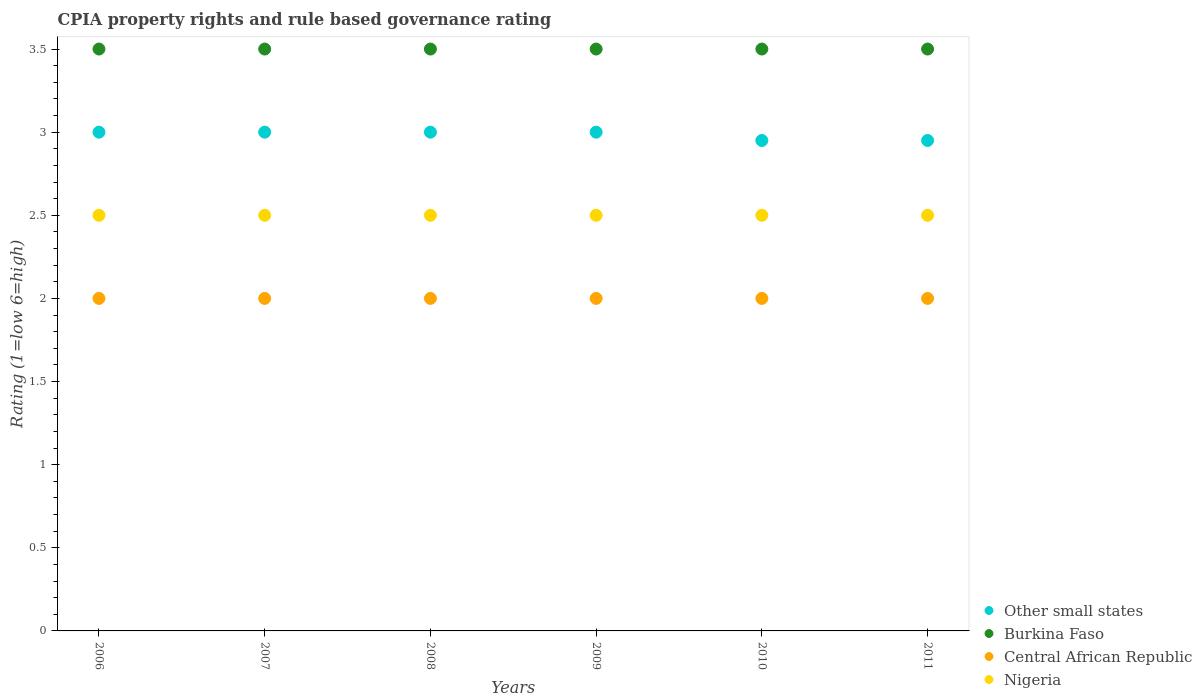How many different coloured dotlines are there?
Give a very brief answer. 4. Is the number of dotlines equal to the number of legend labels?
Give a very brief answer. Yes. Across all years, what is the maximum CPIA rating in Nigeria?
Give a very brief answer. 2.5. Across all years, what is the minimum CPIA rating in Other small states?
Ensure brevity in your answer.  2.95. In which year was the CPIA rating in Other small states maximum?
Your response must be concise. 2006. What is the total CPIA rating in Other small states in the graph?
Give a very brief answer. 17.9. What is the difference between the CPIA rating in Central African Republic in 2010 and the CPIA rating in Nigeria in 2008?
Give a very brief answer. -0.5. What is the average CPIA rating in Burkina Faso per year?
Your response must be concise. 3.5. In the year 2008, what is the difference between the CPIA rating in Burkina Faso and CPIA rating in Central African Republic?
Your response must be concise. 1.5. What is the difference between the highest and the second highest CPIA rating in Central African Republic?
Provide a succinct answer. 0. In how many years, is the CPIA rating in Other small states greater than the average CPIA rating in Other small states taken over all years?
Your answer should be compact. 4. Is it the case that in every year, the sum of the CPIA rating in Nigeria and CPIA rating in Central African Republic  is greater than the sum of CPIA rating in Other small states and CPIA rating in Burkina Faso?
Provide a short and direct response. Yes. Does the CPIA rating in Central African Republic monotonically increase over the years?
Your answer should be very brief. No. Is the CPIA rating in Nigeria strictly greater than the CPIA rating in Central African Republic over the years?
Keep it short and to the point. Yes. Is the CPIA rating in Central African Republic strictly less than the CPIA rating in Other small states over the years?
Keep it short and to the point. Yes. What is the difference between two consecutive major ticks on the Y-axis?
Ensure brevity in your answer.  0.5. Does the graph contain any zero values?
Your answer should be compact. No. Does the graph contain grids?
Make the answer very short. No. Where does the legend appear in the graph?
Your response must be concise. Bottom right. How many legend labels are there?
Your response must be concise. 4. How are the legend labels stacked?
Your response must be concise. Vertical. What is the title of the graph?
Offer a terse response. CPIA property rights and rule based governance rating. What is the label or title of the Y-axis?
Your answer should be compact. Rating (1=low 6=high). What is the Rating (1=low 6=high) of Burkina Faso in 2006?
Your answer should be very brief. 3.5. What is the Rating (1=low 6=high) in Nigeria in 2006?
Your answer should be very brief. 2.5. What is the Rating (1=low 6=high) in Central African Republic in 2007?
Ensure brevity in your answer.  2. What is the Rating (1=low 6=high) in Nigeria in 2007?
Make the answer very short. 2.5. What is the Rating (1=low 6=high) in Burkina Faso in 2009?
Provide a short and direct response. 3.5. What is the Rating (1=low 6=high) in Central African Republic in 2009?
Offer a terse response. 2. What is the Rating (1=low 6=high) of Other small states in 2010?
Your answer should be compact. 2.95. What is the Rating (1=low 6=high) in Central African Republic in 2010?
Give a very brief answer. 2. What is the Rating (1=low 6=high) of Other small states in 2011?
Provide a short and direct response. 2.95. What is the Rating (1=low 6=high) of Burkina Faso in 2011?
Offer a very short reply. 3.5. What is the Rating (1=low 6=high) in Nigeria in 2011?
Offer a very short reply. 2.5. Across all years, what is the maximum Rating (1=low 6=high) of Nigeria?
Your response must be concise. 2.5. Across all years, what is the minimum Rating (1=low 6=high) of Other small states?
Give a very brief answer. 2.95. Across all years, what is the minimum Rating (1=low 6=high) in Burkina Faso?
Ensure brevity in your answer.  3.5. Across all years, what is the minimum Rating (1=low 6=high) in Nigeria?
Offer a terse response. 2.5. What is the total Rating (1=low 6=high) in Other small states in the graph?
Offer a terse response. 17.9. What is the total Rating (1=low 6=high) of Nigeria in the graph?
Make the answer very short. 15. What is the difference between the Rating (1=low 6=high) of Other small states in 2006 and that in 2007?
Your response must be concise. 0. What is the difference between the Rating (1=low 6=high) of Central African Republic in 2006 and that in 2007?
Provide a succinct answer. 0. What is the difference between the Rating (1=low 6=high) of Nigeria in 2006 and that in 2007?
Keep it short and to the point. 0. What is the difference between the Rating (1=low 6=high) of Other small states in 2006 and that in 2008?
Ensure brevity in your answer.  0. What is the difference between the Rating (1=low 6=high) in Burkina Faso in 2006 and that in 2008?
Offer a terse response. 0. What is the difference between the Rating (1=low 6=high) in Burkina Faso in 2006 and that in 2009?
Keep it short and to the point. 0. What is the difference between the Rating (1=low 6=high) of Other small states in 2006 and that in 2010?
Offer a terse response. 0.05. What is the difference between the Rating (1=low 6=high) of Burkina Faso in 2006 and that in 2010?
Your answer should be very brief. 0. What is the difference between the Rating (1=low 6=high) in Burkina Faso in 2006 and that in 2011?
Offer a terse response. 0. What is the difference between the Rating (1=low 6=high) in Central African Republic in 2006 and that in 2011?
Offer a terse response. 0. What is the difference between the Rating (1=low 6=high) of Burkina Faso in 2007 and that in 2008?
Provide a short and direct response. 0. What is the difference between the Rating (1=low 6=high) of Nigeria in 2007 and that in 2008?
Your response must be concise. 0. What is the difference between the Rating (1=low 6=high) in Other small states in 2007 and that in 2009?
Your answer should be compact. 0. What is the difference between the Rating (1=low 6=high) in Burkina Faso in 2007 and that in 2009?
Offer a terse response. 0. What is the difference between the Rating (1=low 6=high) in Central African Republic in 2007 and that in 2009?
Offer a very short reply. 0. What is the difference between the Rating (1=low 6=high) in Burkina Faso in 2007 and that in 2010?
Offer a very short reply. 0. What is the difference between the Rating (1=low 6=high) in Other small states in 2007 and that in 2011?
Make the answer very short. 0.05. What is the difference between the Rating (1=low 6=high) of Burkina Faso in 2007 and that in 2011?
Keep it short and to the point. 0. What is the difference between the Rating (1=low 6=high) in Central African Republic in 2007 and that in 2011?
Ensure brevity in your answer.  0. What is the difference between the Rating (1=low 6=high) in Nigeria in 2007 and that in 2011?
Your answer should be compact. 0. What is the difference between the Rating (1=low 6=high) in Other small states in 2008 and that in 2009?
Your answer should be very brief. 0. What is the difference between the Rating (1=low 6=high) in Nigeria in 2008 and that in 2009?
Ensure brevity in your answer.  0. What is the difference between the Rating (1=low 6=high) of Other small states in 2008 and that in 2010?
Make the answer very short. 0.05. What is the difference between the Rating (1=low 6=high) of Burkina Faso in 2008 and that in 2011?
Make the answer very short. 0. What is the difference between the Rating (1=low 6=high) of Other small states in 2009 and that in 2010?
Offer a terse response. 0.05. What is the difference between the Rating (1=low 6=high) in Burkina Faso in 2009 and that in 2010?
Your answer should be very brief. 0. What is the difference between the Rating (1=low 6=high) of Nigeria in 2009 and that in 2010?
Offer a very short reply. 0. What is the difference between the Rating (1=low 6=high) of Burkina Faso in 2009 and that in 2011?
Provide a succinct answer. 0. What is the difference between the Rating (1=low 6=high) of Central African Republic in 2009 and that in 2011?
Keep it short and to the point. 0. What is the difference between the Rating (1=low 6=high) of Nigeria in 2009 and that in 2011?
Provide a succinct answer. 0. What is the difference between the Rating (1=low 6=high) in Other small states in 2010 and that in 2011?
Your response must be concise. 0. What is the difference between the Rating (1=low 6=high) in Burkina Faso in 2010 and that in 2011?
Your answer should be very brief. 0. What is the difference between the Rating (1=low 6=high) of Nigeria in 2010 and that in 2011?
Offer a terse response. 0. What is the difference between the Rating (1=low 6=high) in Burkina Faso in 2006 and the Rating (1=low 6=high) in Central African Republic in 2007?
Give a very brief answer. 1.5. What is the difference between the Rating (1=low 6=high) in Burkina Faso in 2006 and the Rating (1=low 6=high) in Nigeria in 2007?
Offer a terse response. 1. What is the difference between the Rating (1=low 6=high) of Central African Republic in 2006 and the Rating (1=low 6=high) of Nigeria in 2007?
Your answer should be very brief. -0.5. What is the difference between the Rating (1=low 6=high) in Other small states in 2006 and the Rating (1=low 6=high) in Central African Republic in 2008?
Your answer should be compact. 1. What is the difference between the Rating (1=low 6=high) in Burkina Faso in 2006 and the Rating (1=low 6=high) in Central African Republic in 2008?
Provide a succinct answer. 1.5. What is the difference between the Rating (1=low 6=high) of Burkina Faso in 2006 and the Rating (1=low 6=high) of Nigeria in 2008?
Give a very brief answer. 1. What is the difference between the Rating (1=low 6=high) of Central African Republic in 2006 and the Rating (1=low 6=high) of Nigeria in 2008?
Offer a terse response. -0.5. What is the difference between the Rating (1=low 6=high) of Other small states in 2006 and the Rating (1=low 6=high) of Nigeria in 2009?
Provide a succinct answer. 0.5. What is the difference between the Rating (1=low 6=high) in Burkina Faso in 2006 and the Rating (1=low 6=high) in Central African Republic in 2009?
Provide a succinct answer. 1.5. What is the difference between the Rating (1=low 6=high) in Burkina Faso in 2006 and the Rating (1=low 6=high) in Nigeria in 2009?
Provide a short and direct response. 1. What is the difference between the Rating (1=low 6=high) in Central African Republic in 2006 and the Rating (1=low 6=high) in Nigeria in 2009?
Provide a short and direct response. -0.5. What is the difference between the Rating (1=low 6=high) of Other small states in 2006 and the Rating (1=low 6=high) of Central African Republic in 2010?
Make the answer very short. 1. What is the difference between the Rating (1=low 6=high) in Burkina Faso in 2006 and the Rating (1=low 6=high) in Central African Republic in 2010?
Your answer should be compact. 1.5. What is the difference between the Rating (1=low 6=high) of Burkina Faso in 2006 and the Rating (1=low 6=high) of Nigeria in 2010?
Keep it short and to the point. 1. What is the difference between the Rating (1=low 6=high) of Central African Republic in 2006 and the Rating (1=low 6=high) of Nigeria in 2010?
Ensure brevity in your answer.  -0.5. What is the difference between the Rating (1=low 6=high) of Other small states in 2006 and the Rating (1=low 6=high) of Burkina Faso in 2011?
Make the answer very short. -0.5. What is the difference between the Rating (1=low 6=high) in Other small states in 2006 and the Rating (1=low 6=high) in Central African Republic in 2011?
Keep it short and to the point. 1. What is the difference between the Rating (1=low 6=high) of Other small states in 2006 and the Rating (1=low 6=high) of Nigeria in 2011?
Offer a terse response. 0.5. What is the difference between the Rating (1=low 6=high) of Burkina Faso in 2006 and the Rating (1=low 6=high) of Nigeria in 2011?
Your answer should be compact. 1. What is the difference between the Rating (1=low 6=high) of Burkina Faso in 2007 and the Rating (1=low 6=high) of Central African Republic in 2008?
Your answer should be compact. 1.5. What is the difference between the Rating (1=low 6=high) of Other small states in 2007 and the Rating (1=low 6=high) of Burkina Faso in 2009?
Give a very brief answer. -0.5. What is the difference between the Rating (1=low 6=high) of Central African Republic in 2007 and the Rating (1=low 6=high) of Nigeria in 2009?
Make the answer very short. -0.5. What is the difference between the Rating (1=low 6=high) in Burkina Faso in 2007 and the Rating (1=low 6=high) in Central African Republic in 2010?
Give a very brief answer. 1.5. What is the difference between the Rating (1=low 6=high) of Central African Republic in 2007 and the Rating (1=low 6=high) of Nigeria in 2010?
Provide a short and direct response. -0.5. What is the difference between the Rating (1=low 6=high) of Other small states in 2007 and the Rating (1=low 6=high) of Burkina Faso in 2011?
Ensure brevity in your answer.  -0.5. What is the difference between the Rating (1=low 6=high) in Other small states in 2007 and the Rating (1=low 6=high) in Central African Republic in 2011?
Ensure brevity in your answer.  1. What is the difference between the Rating (1=low 6=high) in Other small states in 2007 and the Rating (1=low 6=high) in Nigeria in 2011?
Keep it short and to the point. 0.5. What is the difference between the Rating (1=low 6=high) of Burkina Faso in 2007 and the Rating (1=low 6=high) of Central African Republic in 2011?
Provide a short and direct response. 1.5. What is the difference between the Rating (1=low 6=high) in Burkina Faso in 2007 and the Rating (1=low 6=high) in Nigeria in 2011?
Your response must be concise. 1. What is the difference between the Rating (1=low 6=high) in Central African Republic in 2007 and the Rating (1=low 6=high) in Nigeria in 2011?
Your answer should be very brief. -0.5. What is the difference between the Rating (1=low 6=high) in Other small states in 2008 and the Rating (1=low 6=high) in Nigeria in 2009?
Provide a succinct answer. 0.5. What is the difference between the Rating (1=low 6=high) in Burkina Faso in 2008 and the Rating (1=low 6=high) in Central African Republic in 2009?
Your answer should be very brief. 1.5. What is the difference between the Rating (1=low 6=high) of Other small states in 2008 and the Rating (1=low 6=high) of Central African Republic in 2010?
Make the answer very short. 1. What is the difference between the Rating (1=low 6=high) of Burkina Faso in 2008 and the Rating (1=low 6=high) of Nigeria in 2010?
Your response must be concise. 1. What is the difference between the Rating (1=low 6=high) in Other small states in 2008 and the Rating (1=low 6=high) in Burkina Faso in 2011?
Provide a short and direct response. -0.5. What is the difference between the Rating (1=low 6=high) in Other small states in 2008 and the Rating (1=low 6=high) in Central African Republic in 2011?
Ensure brevity in your answer.  1. What is the difference between the Rating (1=low 6=high) of Central African Republic in 2008 and the Rating (1=low 6=high) of Nigeria in 2011?
Your response must be concise. -0.5. What is the difference between the Rating (1=low 6=high) in Other small states in 2009 and the Rating (1=low 6=high) in Burkina Faso in 2010?
Your answer should be very brief. -0.5. What is the difference between the Rating (1=low 6=high) in Other small states in 2009 and the Rating (1=low 6=high) in Central African Republic in 2010?
Your response must be concise. 1. What is the difference between the Rating (1=low 6=high) in Other small states in 2009 and the Rating (1=low 6=high) in Nigeria in 2010?
Make the answer very short. 0.5. What is the difference between the Rating (1=low 6=high) of Burkina Faso in 2009 and the Rating (1=low 6=high) of Central African Republic in 2010?
Offer a very short reply. 1.5. What is the difference between the Rating (1=low 6=high) of Burkina Faso in 2009 and the Rating (1=low 6=high) of Nigeria in 2010?
Keep it short and to the point. 1. What is the difference between the Rating (1=low 6=high) of Other small states in 2009 and the Rating (1=low 6=high) of Nigeria in 2011?
Keep it short and to the point. 0.5. What is the difference between the Rating (1=low 6=high) of Burkina Faso in 2009 and the Rating (1=low 6=high) of Central African Republic in 2011?
Offer a very short reply. 1.5. What is the difference between the Rating (1=low 6=high) in Burkina Faso in 2009 and the Rating (1=low 6=high) in Nigeria in 2011?
Provide a succinct answer. 1. What is the difference between the Rating (1=low 6=high) in Central African Republic in 2009 and the Rating (1=low 6=high) in Nigeria in 2011?
Your answer should be very brief. -0.5. What is the difference between the Rating (1=low 6=high) of Other small states in 2010 and the Rating (1=low 6=high) of Burkina Faso in 2011?
Offer a very short reply. -0.55. What is the difference between the Rating (1=low 6=high) of Other small states in 2010 and the Rating (1=low 6=high) of Central African Republic in 2011?
Your answer should be compact. 0.95. What is the difference between the Rating (1=low 6=high) in Other small states in 2010 and the Rating (1=low 6=high) in Nigeria in 2011?
Your response must be concise. 0.45. What is the difference between the Rating (1=low 6=high) of Burkina Faso in 2010 and the Rating (1=low 6=high) of Central African Republic in 2011?
Your response must be concise. 1.5. What is the difference between the Rating (1=low 6=high) of Burkina Faso in 2010 and the Rating (1=low 6=high) of Nigeria in 2011?
Give a very brief answer. 1. What is the difference between the Rating (1=low 6=high) in Central African Republic in 2010 and the Rating (1=low 6=high) in Nigeria in 2011?
Ensure brevity in your answer.  -0.5. What is the average Rating (1=low 6=high) of Other small states per year?
Your answer should be compact. 2.98. What is the average Rating (1=low 6=high) of Central African Republic per year?
Offer a very short reply. 2. In the year 2006, what is the difference between the Rating (1=low 6=high) of Other small states and Rating (1=low 6=high) of Burkina Faso?
Give a very brief answer. -0.5. In the year 2006, what is the difference between the Rating (1=low 6=high) in Other small states and Rating (1=low 6=high) in Central African Republic?
Your answer should be very brief. 1. In the year 2006, what is the difference between the Rating (1=low 6=high) of Burkina Faso and Rating (1=low 6=high) of Nigeria?
Ensure brevity in your answer.  1. In the year 2007, what is the difference between the Rating (1=low 6=high) of Other small states and Rating (1=low 6=high) of Nigeria?
Offer a very short reply. 0.5. In the year 2007, what is the difference between the Rating (1=low 6=high) of Central African Republic and Rating (1=low 6=high) of Nigeria?
Your response must be concise. -0.5. In the year 2008, what is the difference between the Rating (1=low 6=high) in Other small states and Rating (1=low 6=high) in Central African Republic?
Your answer should be very brief. 1. In the year 2008, what is the difference between the Rating (1=low 6=high) of Burkina Faso and Rating (1=low 6=high) of Central African Republic?
Your response must be concise. 1.5. In the year 2008, what is the difference between the Rating (1=low 6=high) in Burkina Faso and Rating (1=low 6=high) in Nigeria?
Make the answer very short. 1. In the year 2009, what is the difference between the Rating (1=low 6=high) of Other small states and Rating (1=low 6=high) of Burkina Faso?
Provide a succinct answer. -0.5. In the year 2009, what is the difference between the Rating (1=low 6=high) of Burkina Faso and Rating (1=low 6=high) of Central African Republic?
Your answer should be compact. 1.5. In the year 2009, what is the difference between the Rating (1=low 6=high) in Burkina Faso and Rating (1=low 6=high) in Nigeria?
Keep it short and to the point. 1. In the year 2010, what is the difference between the Rating (1=low 6=high) of Other small states and Rating (1=low 6=high) of Burkina Faso?
Provide a succinct answer. -0.55. In the year 2010, what is the difference between the Rating (1=low 6=high) in Other small states and Rating (1=low 6=high) in Central African Republic?
Offer a terse response. 0.95. In the year 2010, what is the difference between the Rating (1=low 6=high) in Other small states and Rating (1=low 6=high) in Nigeria?
Give a very brief answer. 0.45. In the year 2010, what is the difference between the Rating (1=low 6=high) of Burkina Faso and Rating (1=low 6=high) of Central African Republic?
Your answer should be compact. 1.5. In the year 2010, what is the difference between the Rating (1=low 6=high) in Central African Republic and Rating (1=low 6=high) in Nigeria?
Keep it short and to the point. -0.5. In the year 2011, what is the difference between the Rating (1=low 6=high) of Other small states and Rating (1=low 6=high) of Burkina Faso?
Your answer should be very brief. -0.55. In the year 2011, what is the difference between the Rating (1=low 6=high) of Other small states and Rating (1=low 6=high) of Central African Republic?
Keep it short and to the point. 0.95. In the year 2011, what is the difference between the Rating (1=low 6=high) of Other small states and Rating (1=low 6=high) of Nigeria?
Make the answer very short. 0.45. In the year 2011, what is the difference between the Rating (1=low 6=high) of Burkina Faso and Rating (1=low 6=high) of Central African Republic?
Make the answer very short. 1.5. In the year 2011, what is the difference between the Rating (1=low 6=high) in Burkina Faso and Rating (1=low 6=high) in Nigeria?
Offer a very short reply. 1. What is the ratio of the Rating (1=low 6=high) of Burkina Faso in 2006 to that in 2007?
Your answer should be very brief. 1. What is the ratio of the Rating (1=low 6=high) in Central African Republic in 2006 to that in 2007?
Provide a succinct answer. 1. What is the ratio of the Rating (1=low 6=high) of Central African Republic in 2006 to that in 2008?
Keep it short and to the point. 1. What is the ratio of the Rating (1=low 6=high) in Other small states in 2006 to that in 2009?
Ensure brevity in your answer.  1. What is the ratio of the Rating (1=low 6=high) of Burkina Faso in 2006 to that in 2009?
Give a very brief answer. 1. What is the ratio of the Rating (1=low 6=high) in Other small states in 2006 to that in 2010?
Your response must be concise. 1.02. What is the ratio of the Rating (1=low 6=high) of Central African Republic in 2006 to that in 2010?
Keep it short and to the point. 1. What is the ratio of the Rating (1=low 6=high) in Other small states in 2006 to that in 2011?
Give a very brief answer. 1.02. What is the ratio of the Rating (1=low 6=high) in Nigeria in 2006 to that in 2011?
Your answer should be compact. 1. What is the ratio of the Rating (1=low 6=high) of Nigeria in 2007 to that in 2008?
Your answer should be very brief. 1. What is the ratio of the Rating (1=low 6=high) in Other small states in 2007 to that in 2009?
Your answer should be very brief. 1. What is the ratio of the Rating (1=low 6=high) of Burkina Faso in 2007 to that in 2009?
Offer a very short reply. 1. What is the ratio of the Rating (1=low 6=high) in Central African Republic in 2007 to that in 2009?
Your answer should be very brief. 1. What is the ratio of the Rating (1=low 6=high) of Other small states in 2007 to that in 2010?
Your answer should be compact. 1.02. What is the ratio of the Rating (1=low 6=high) of Nigeria in 2007 to that in 2010?
Offer a very short reply. 1. What is the ratio of the Rating (1=low 6=high) in Other small states in 2007 to that in 2011?
Make the answer very short. 1.02. What is the ratio of the Rating (1=low 6=high) in Nigeria in 2007 to that in 2011?
Provide a succinct answer. 1. What is the ratio of the Rating (1=low 6=high) in Central African Republic in 2008 to that in 2009?
Provide a succinct answer. 1. What is the ratio of the Rating (1=low 6=high) of Nigeria in 2008 to that in 2009?
Your answer should be compact. 1. What is the ratio of the Rating (1=low 6=high) in Other small states in 2008 to that in 2010?
Provide a succinct answer. 1.02. What is the ratio of the Rating (1=low 6=high) in Central African Republic in 2008 to that in 2010?
Provide a short and direct response. 1. What is the ratio of the Rating (1=low 6=high) of Nigeria in 2008 to that in 2010?
Your response must be concise. 1. What is the ratio of the Rating (1=low 6=high) in Other small states in 2008 to that in 2011?
Keep it short and to the point. 1.02. What is the ratio of the Rating (1=low 6=high) in Burkina Faso in 2008 to that in 2011?
Offer a terse response. 1. What is the ratio of the Rating (1=low 6=high) in Central African Republic in 2008 to that in 2011?
Provide a succinct answer. 1. What is the ratio of the Rating (1=low 6=high) in Other small states in 2009 to that in 2010?
Offer a very short reply. 1.02. What is the ratio of the Rating (1=low 6=high) in Burkina Faso in 2009 to that in 2010?
Offer a terse response. 1. What is the ratio of the Rating (1=low 6=high) of Central African Republic in 2009 to that in 2010?
Give a very brief answer. 1. What is the ratio of the Rating (1=low 6=high) of Nigeria in 2009 to that in 2010?
Your response must be concise. 1. What is the ratio of the Rating (1=low 6=high) of Other small states in 2009 to that in 2011?
Ensure brevity in your answer.  1.02. What is the ratio of the Rating (1=low 6=high) of Burkina Faso in 2009 to that in 2011?
Keep it short and to the point. 1. What is the ratio of the Rating (1=low 6=high) of Central African Republic in 2009 to that in 2011?
Provide a short and direct response. 1. What is the ratio of the Rating (1=low 6=high) in Nigeria in 2009 to that in 2011?
Give a very brief answer. 1. What is the ratio of the Rating (1=low 6=high) of Burkina Faso in 2010 to that in 2011?
Offer a terse response. 1. What is the ratio of the Rating (1=low 6=high) of Central African Republic in 2010 to that in 2011?
Offer a very short reply. 1. What is the difference between the highest and the second highest Rating (1=low 6=high) in Other small states?
Ensure brevity in your answer.  0. What is the difference between the highest and the second highest Rating (1=low 6=high) in Burkina Faso?
Your answer should be compact. 0. What is the difference between the highest and the second highest Rating (1=low 6=high) in Central African Republic?
Your answer should be compact. 0. What is the difference between the highest and the lowest Rating (1=low 6=high) of Other small states?
Provide a succinct answer. 0.05. 